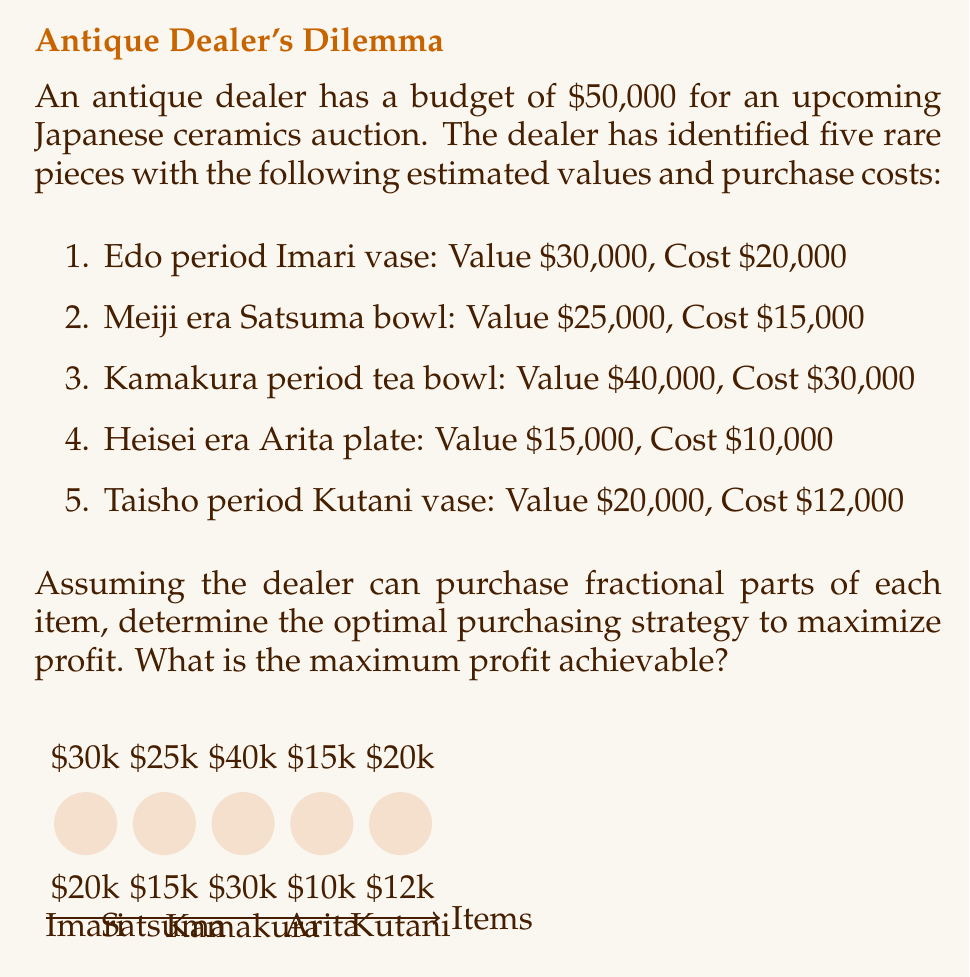Can you solve this math problem? To solve this optimization problem, we'll use the concept of marginal profit ratio and the greedy algorithm approach. Here's a step-by-step solution:

1) Calculate the marginal profit ratio for each item:
   Marginal profit ratio = (Value - Cost) / Cost

   For each item:
   - Imari vase: $(30000 - 20000) / 20000 = 0.5$
   - Satsuma bowl: $(25000 - 15000) / 15000 \approx 0.67$
   - Kamakura tea bowl: $(40000 - 30000) / 30000 \approx 0.33$
   - Arita plate: $(15000 - 10000) / 10000 = 0.5$
   - Kutani vase: $(20000 - 12000) / 12000 \approx 0.67$

2) Rank the items by their marginal profit ratio (highest to lowest):
   1. Satsuma bowl (0.67)
   2. Kutani vase (0.67)
   3. Imari vase (0.5)
   4. Arita plate (0.5)
   5. Kamakura tea bowl (0.33)

3) Allocate the budget starting with the highest marginal profit ratio:
   - Satsuma bowl: $15,000 (fully purchased)
   - Kutani vase: $12,000 (fully purchased)
   - Imari vase: $20,000 (fully purchased)
   - Arita plate: $3,000 (partially purchased, 30% of its cost)

   Total spent: $15,000 + $12,000 + $20,000 + $3,000 = $50,000 (full budget used)

4) Calculate the profit:
   - Satsuma bowl: $25,000 - $15,000 = $10,000
   - Kutani vase: $20,000 - $12,000 = $8,000
   - Imari vase: $30,000 - $20,000 = $10,000
   - Arita plate (30%): $(15,000 - 10,000) * 0.3 = $1,500

   Total profit: $10,000 + $8,000 + $10,000 + $1,500 = $29,500

Therefore, the maximum achievable profit is $29,500.
Answer: $29,500 